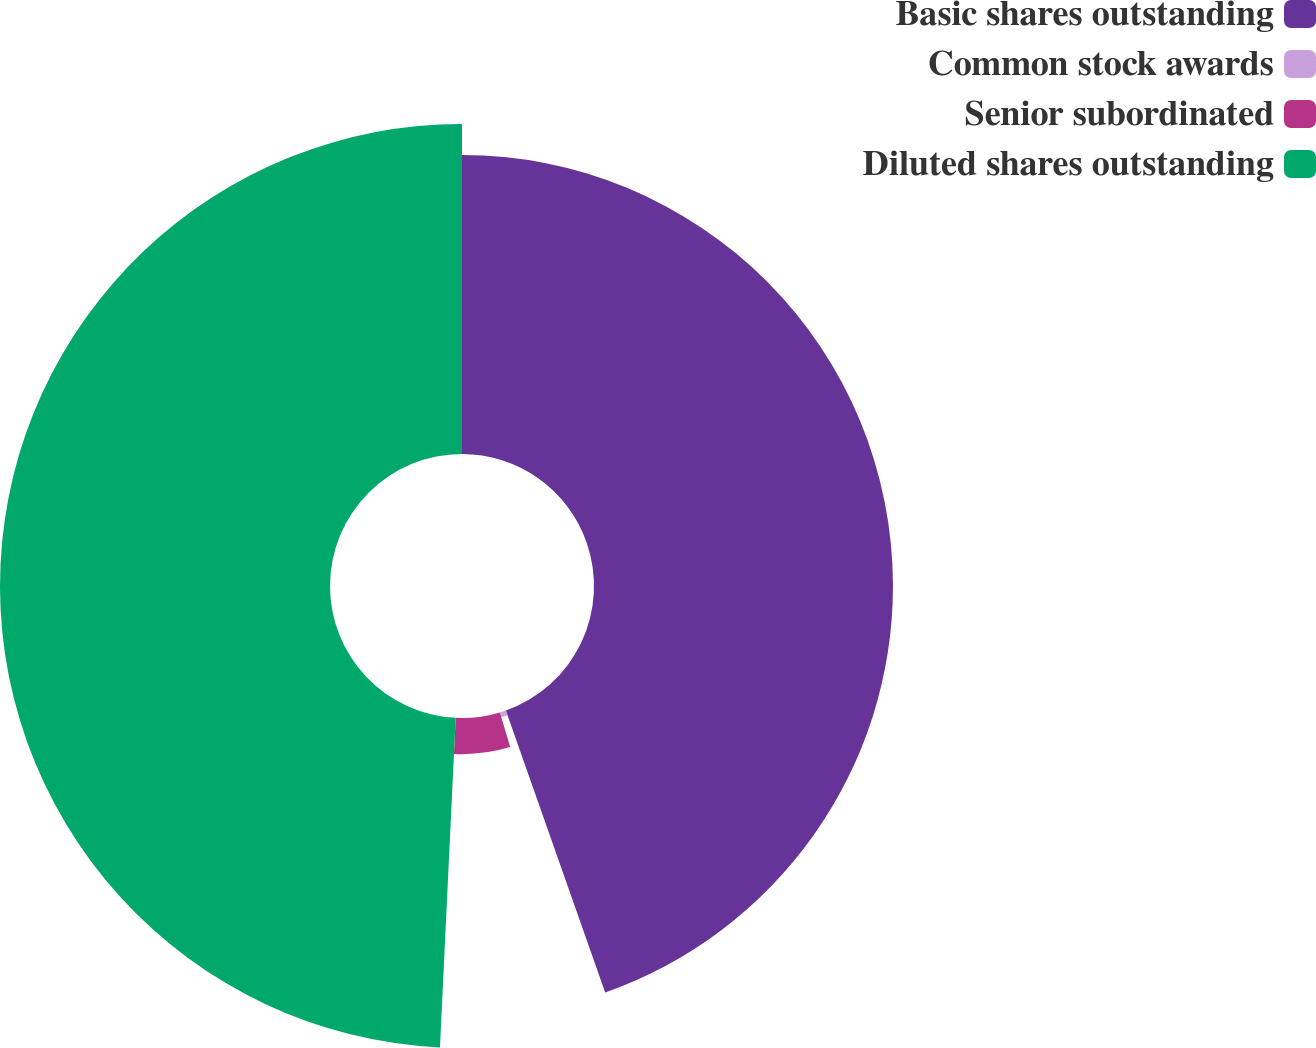Convert chart to OTSL. <chart><loc_0><loc_0><loc_500><loc_500><pie_chart><fcel>Basic shares outstanding<fcel>Common stock awards<fcel>Senior subordinated<fcel>Diluted shares outstanding<nl><fcel>44.61%<fcel>0.76%<fcel>5.39%<fcel>49.24%<nl></chart> 